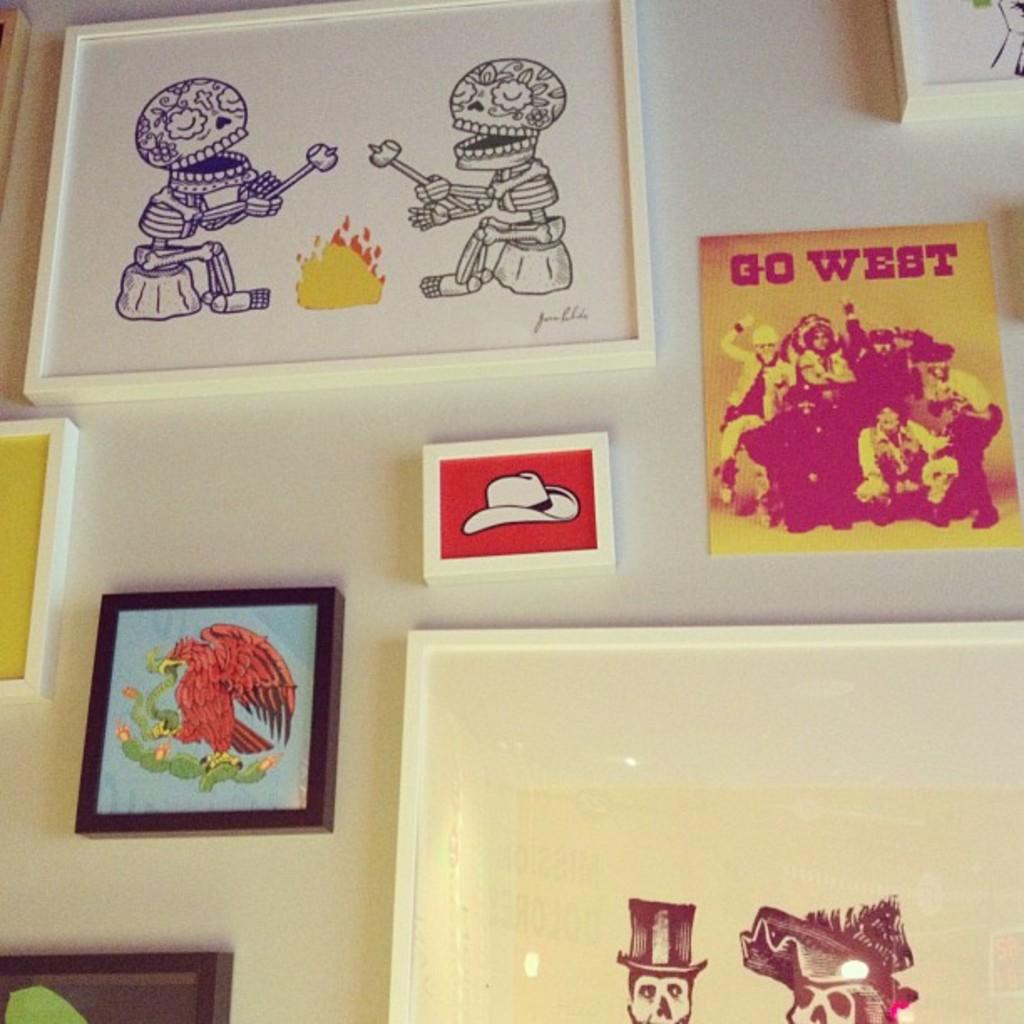What does the picture read?
Ensure brevity in your answer.  Go west. 